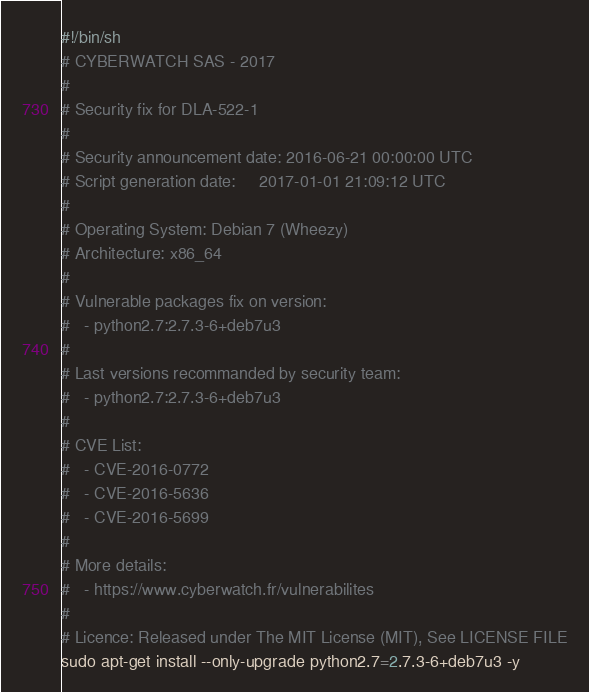Convert code to text. <code><loc_0><loc_0><loc_500><loc_500><_Bash_>#!/bin/sh
# CYBERWATCH SAS - 2017
#
# Security fix for DLA-522-1
#
# Security announcement date: 2016-06-21 00:00:00 UTC
# Script generation date:     2017-01-01 21:09:12 UTC
#
# Operating System: Debian 7 (Wheezy)
# Architecture: x86_64
#
# Vulnerable packages fix on version:
#   - python2.7:2.7.3-6+deb7u3
#
# Last versions recommanded by security team:
#   - python2.7:2.7.3-6+deb7u3
#
# CVE List:
#   - CVE-2016-0772
#   - CVE-2016-5636
#   - CVE-2016-5699
#
# More details:
#   - https://www.cyberwatch.fr/vulnerabilites
#
# Licence: Released under The MIT License (MIT), See LICENSE FILE
sudo apt-get install --only-upgrade python2.7=2.7.3-6+deb7u3 -y
</code> 